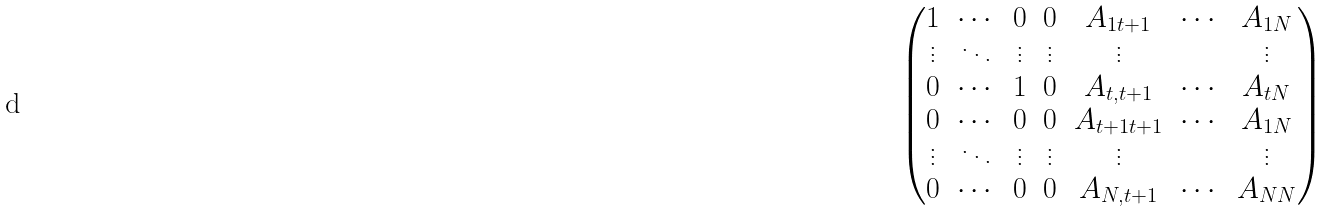Convert formula to latex. <formula><loc_0><loc_0><loc_500><loc_500>\begin{pmatrix} 1 & \cdots & 0 & 0 & A _ { 1 t + 1 } & \cdots & A _ { 1 N } \\ \vdots & \ddots & \vdots & \vdots & \vdots & & \vdots \\ 0 & \cdots & 1 & 0 & A _ { t , t + 1 } & \cdots & A _ { t N } \\ 0 & \cdots & 0 & 0 & A _ { t + 1 t + 1 } & \cdots & A _ { 1 N } \\ \vdots & \ddots & \vdots & \vdots & \vdots & & \vdots \\ 0 & \cdots & 0 & 0 & A _ { N , t + 1 } & \cdots & A _ { N N } \\ \end{pmatrix}</formula> 